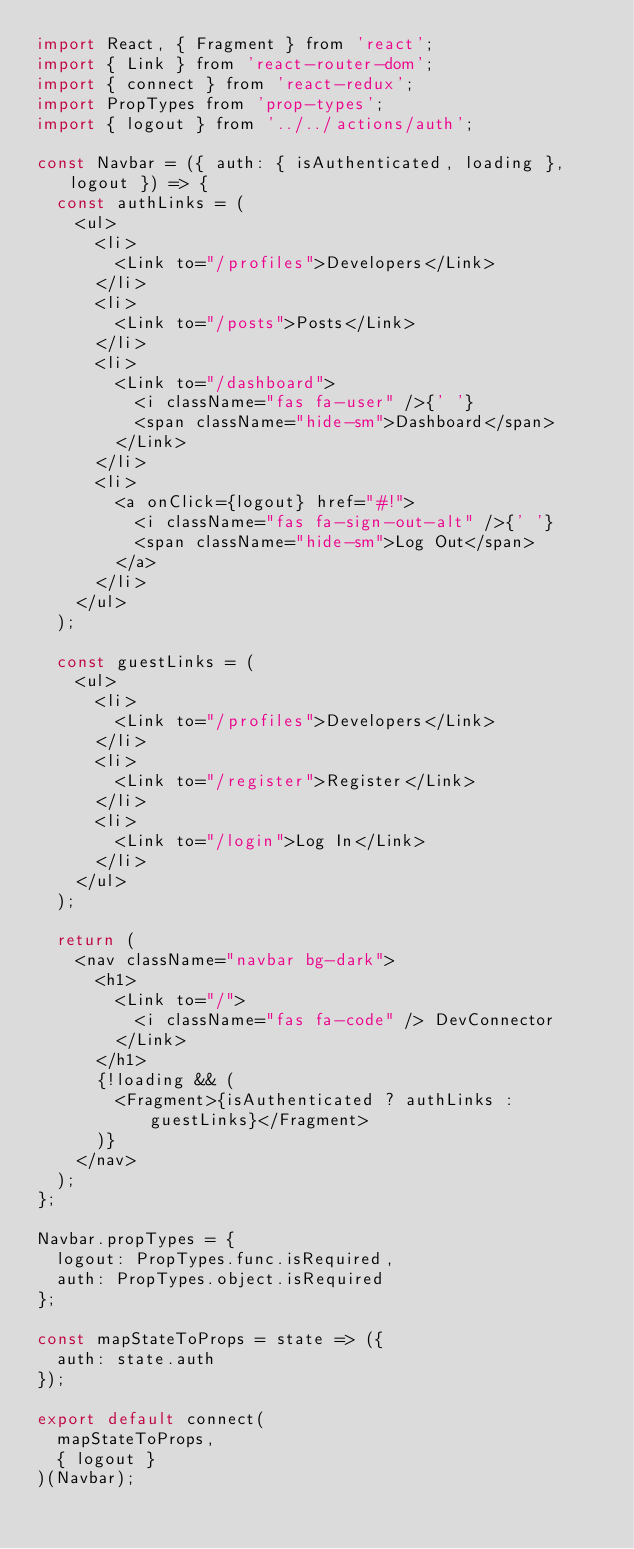<code> <loc_0><loc_0><loc_500><loc_500><_JavaScript_>import React, { Fragment } from 'react';
import { Link } from 'react-router-dom';
import { connect } from 'react-redux';
import PropTypes from 'prop-types';
import { logout } from '../../actions/auth';

const Navbar = ({ auth: { isAuthenticated, loading }, logout }) => {
  const authLinks = (
    <ul>
      <li>
        <Link to="/profiles">Developers</Link>
      </li>
      <li>
        <Link to="/posts">Posts</Link>
      </li>
      <li>
        <Link to="/dashboard">
          <i className="fas fa-user" />{' '}
          <span className="hide-sm">Dashboard</span>
        </Link>
      </li>
      <li>
        <a onClick={logout} href="#!">
          <i className="fas fa-sign-out-alt" />{' '}
          <span className="hide-sm">Log Out</span>
        </a>
      </li>
    </ul>
  );

  const guestLinks = (
    <ul>
      <li>
        <Link to="/profiles">Developers</Link>
      </li>
      <li>
        <Link to="/register">Register</Link>
      </li>
      <li>
        <Link to="/login">Log In</Link>
      </li>
    </ul>
  );

  return (
    <nav className="navbar bg-dark">
      <h1>
        <Link to="/">
          <i className="fas fa-code" /> DevConnector
        </Link>
      </h1>
      {!loading && (
        <Fragment>{isAuthenticated ? authLinks : guestLinks}</Fragment>
      )}
    </nav>
  );
};

Navbar.propTypes = {
  logout: PropTypes.func.isRequired,
  auth: PropTypes.object.isRequired
};

const mapStateToProps = state => ({
  auth: state.auth
});

export default connect(
  mapStateToProps,
  { logout }
)(Navbar);
</code> 